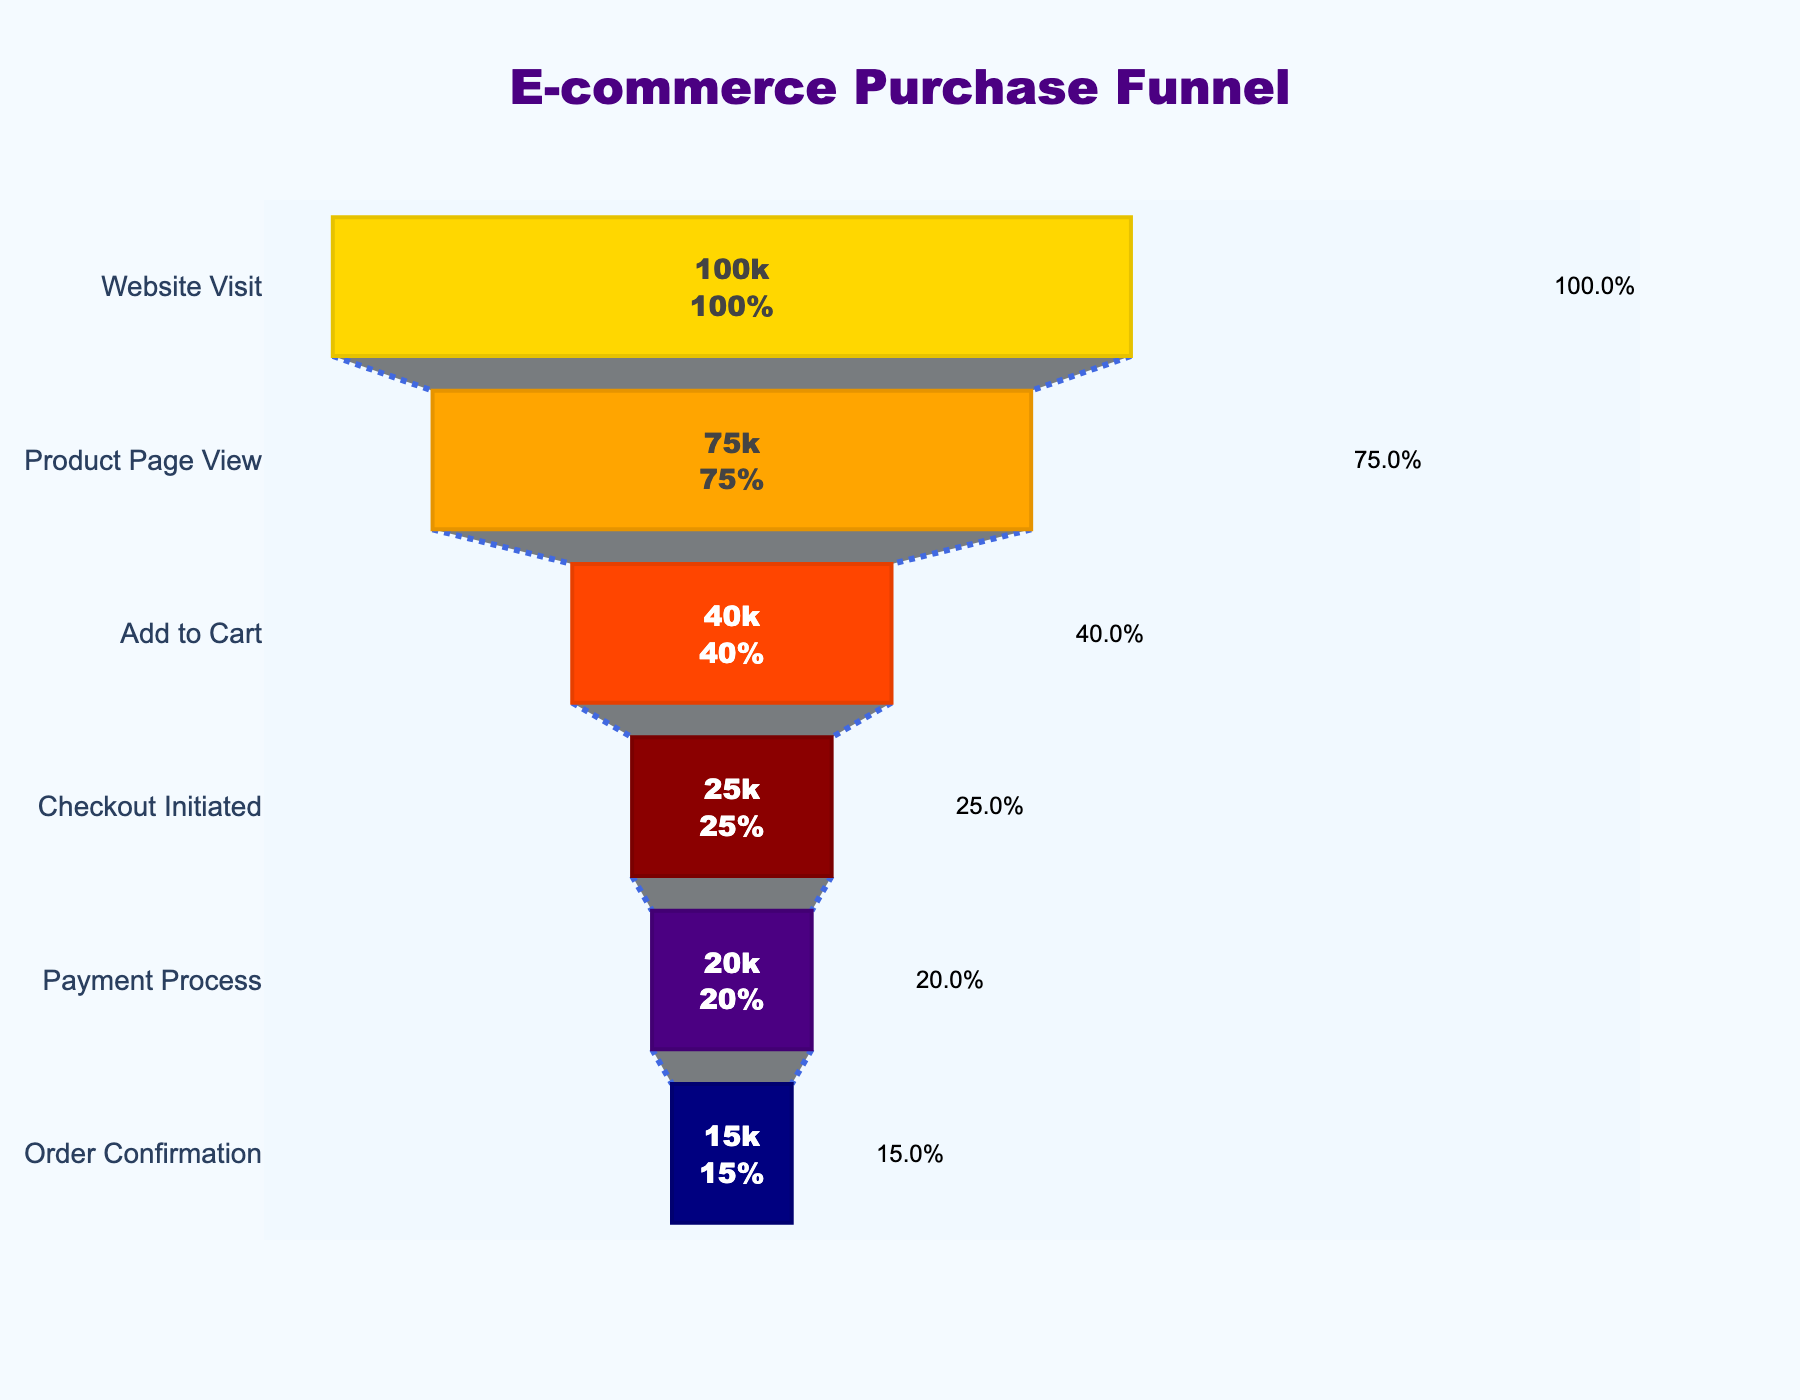What is the title of the chart? The title is displayed at the top of the chart. It is in bold and specifies what the entire chart represents.
Answer: E-commerce Purchase Funnel What is the number of visitors who visited the Product Page? The chart shows 'Product Page View' as one of the funnel stages with the associated number of visitors indicated inside the bar.
Answer: 75000 How many stages are there in the funnel? By counting the distinct stages listed vertically along the funnel, we can determine the total number of stages.
Answer: 6 Which stage has the steepest drop in visitor numbers? To determine this, observe the visitor count at each stage and identify where the largest decrease occurs between consecutive stages.
Answer: Add to Cart What percentage of visitors reached the Payment Process stage? Find the visitor count for the Payment Process stage and divide it by the initial visitor count (Website Visit), then multiply by 100 to get the percentage.
Answer: 20% What is the color of the bar representing 'Order Confirmation'? Each stage is represented by a bar of a specific color. Identify the color used for 'Order Confirmation' from the chart.
Answer: Navy blue How many visitors did not proceed from the Checkout Initiated stage to the Payment Process stage? Subtract the number of visitors in the Payment Process stage from those in the Checkout Initiated stage to find the number who did not proceed.
Answer: 5000 What is the conversion rate from 'Add to Cart' to 'Checkout Initiated' stage? Divide the number of visitors at the 'Checkout Initiated' stage by those at the 'Add to Cart' stage and multiply by 100 to get the conversion rate.
Answer: 62.5% What is the drop-off rate from 'Website Visit' to 'Product Page View'? Subtract the Product Page View visitor count from the Website Visit count, divide by the Website Visit count, and then multiply by 100 to find the drop-off rate.
Answer: 25% Which stage has the second highest conversion rate after the initial stage? Calculate the conversion rates for each stage relative to the initial number of visitors and identify the stage with the second highest value.
Answer: Payment Process 